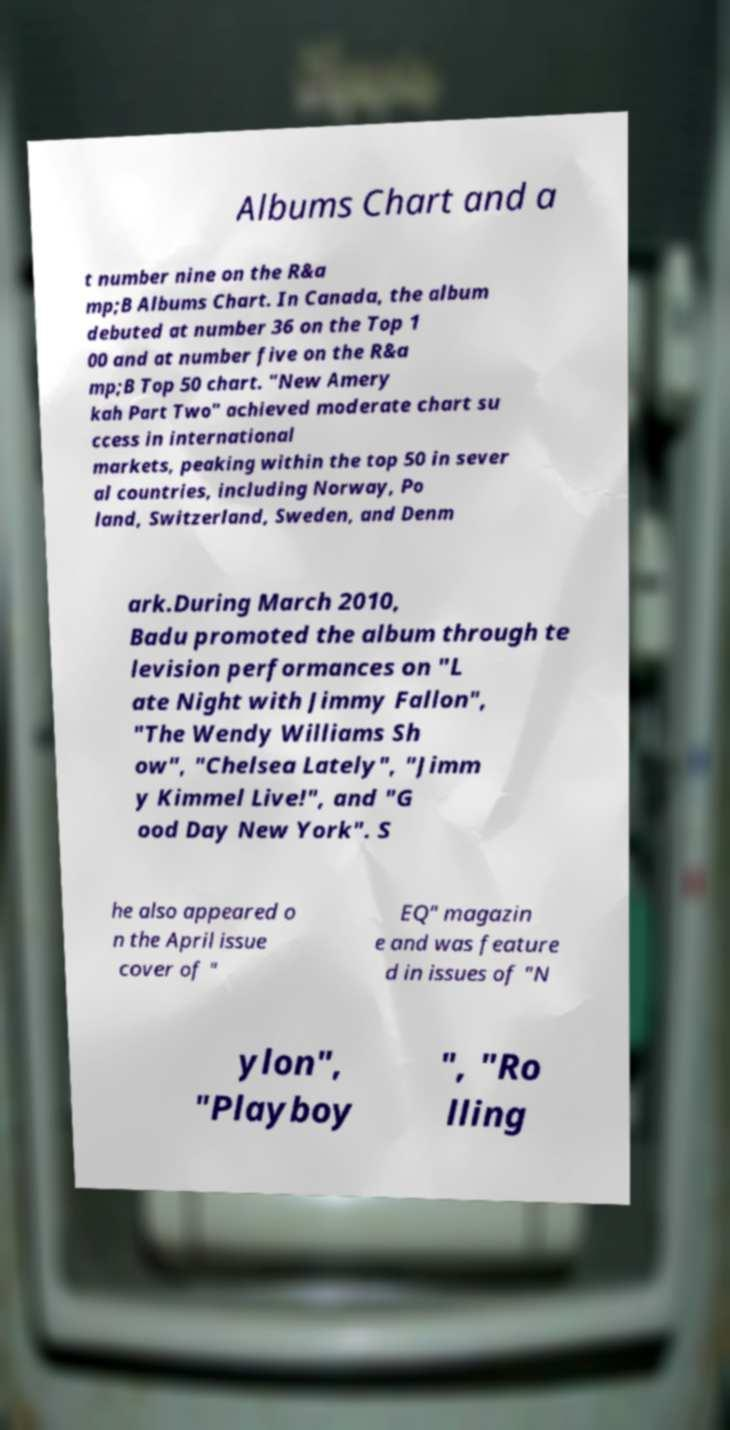For documentation purposes, I need the text within this image transcribed. Could you provide that? Albums Chart and a t number nine on the R&a mp;B Albums Chart. In Canada, the album debuted at number 36 on the Top 1 00 and at number five on the R&a mp;B Top 50 chart. "New Amery kah Part Two" achieved moderate chart su ccess in international markets, peaking within the top 50 in sever al countries, including Norway, Po land, Switzerland, Sweden, and Denm ark.During March 2010, Badu promoted the album through te levision performances on "L ate Night with Jimmy Fallon", "The Wendy Williams Sh ow", "Chelsea Lately", "Jimm y Kimmel Live!", and "G ood Day New York". S he also appeared o n the April issue cover of " EQ" magazin e and was feature d in issues of "N ylon", "Playboy ", "Ro lling 